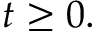Convert formula to latex. <formula><loc_0><loc_0><loc_500><loc_500>t \geq 0 .</formula> 